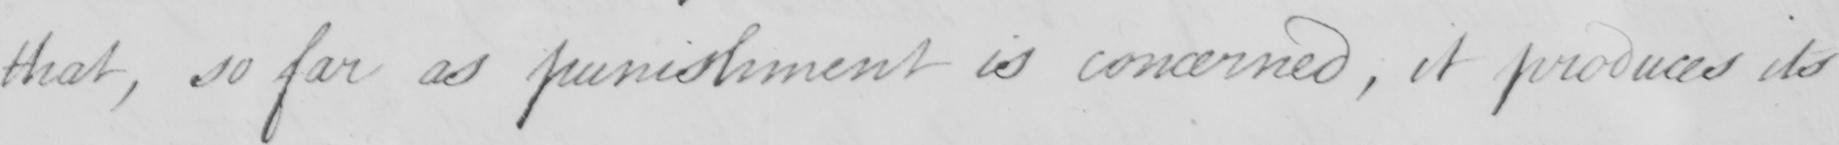Please provide the text content of this handwritten line. that , so far as punishment is concerned  , it produces its 